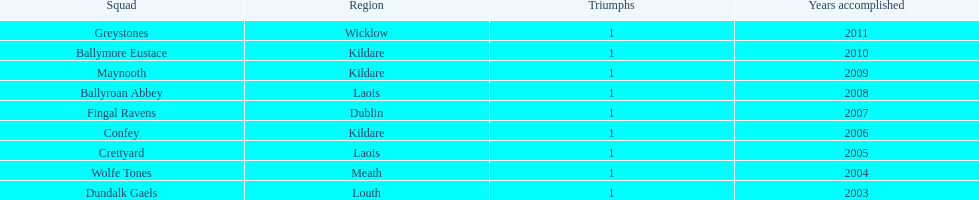What is the number of wins for each team 1. 